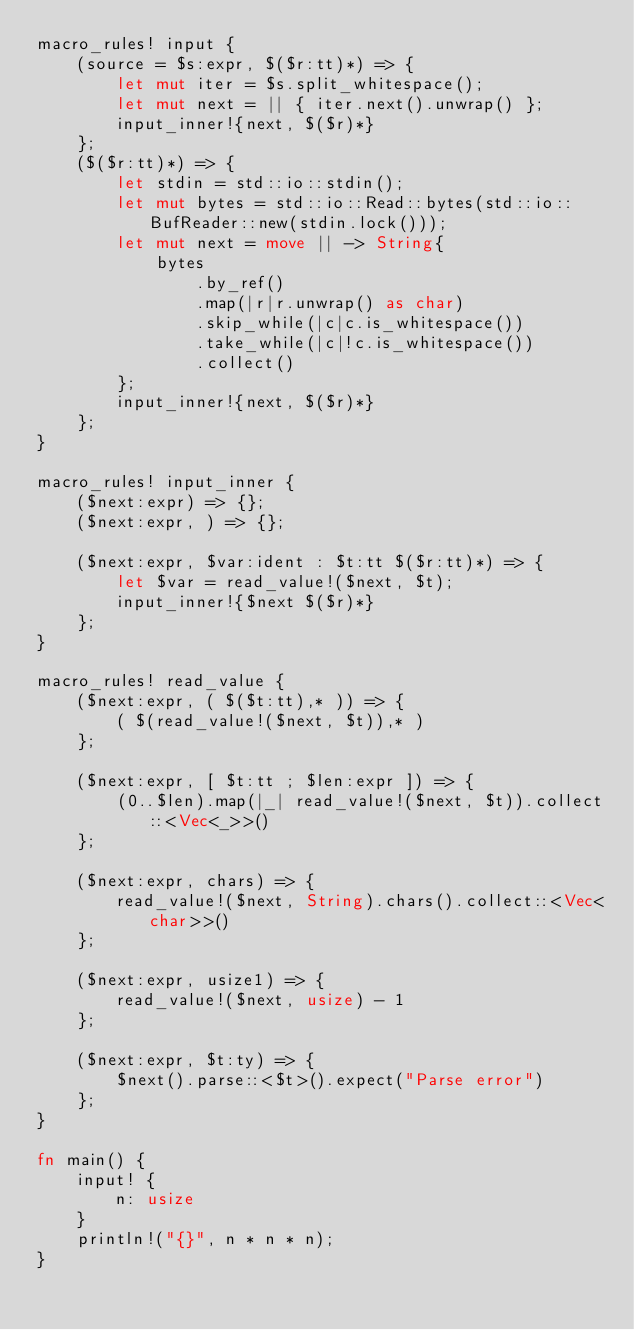Convert code to text. <code><loc_0><loc_0><loc_500><loc_500><_Rust_>macro_rules! input {
    (source = $s:expr, $($r:tt)*) => {
        let mut iter = $s.split_whitespace();
        let mut next = || { iter.next().unwrap() };
        input_inner!{next, $($r)*}
    };
    ($($r:tt)*) => {
        let stdin = std::io::stdin();
        let mut bytes = std::io::Read::bytes(std::io::BufReader::new(stdin.lock()));
        let mut next = move || -> String{
            bytes
                .by_ref()
                .map(|r|r.unwrap() as char)
                .skip_while(|c|c.is_whitespace())
                .take_while(|c|!c.is_whitespace())
                .collect()
        };
        input_inner!{next, $($r)*}
    };
}

macro_rules! input_inner {
    ($next:expr) => {};
    ($next:expr, ) => {};

    ($next:expr, $var:ident : $t:tt $($r:tt)*) => {
        let $var = read_value!($next, $t);
        input_inner!{$next $($r)*}
    };
}

macro_rules! read_value {
    ($next:expr, ( $($t:tt),* )) => {
        ( $(read_value!($next, $t)),* )
    };

    ($next:expr, [ $t:tt ; $len:expr ]) => {
        (0..$len).map(|_| read_value!($next, $t)).collect::<Vec<_>>()
    };

    ($next:expr, chars) => {
        read_value!($next, String).chars().collect::<Vec<char>>()
    };

    ($next:expr, usize1) => {
        read_value!($next, usize) - 1
    };

    ($next:expr, $t:ty) => {
        $next().parse::<$t>().expect("Parse error")
    };
}

fn main() {
    input! {
        n: usize
    }
    println!("{}", n * n * n);
}
</code> 